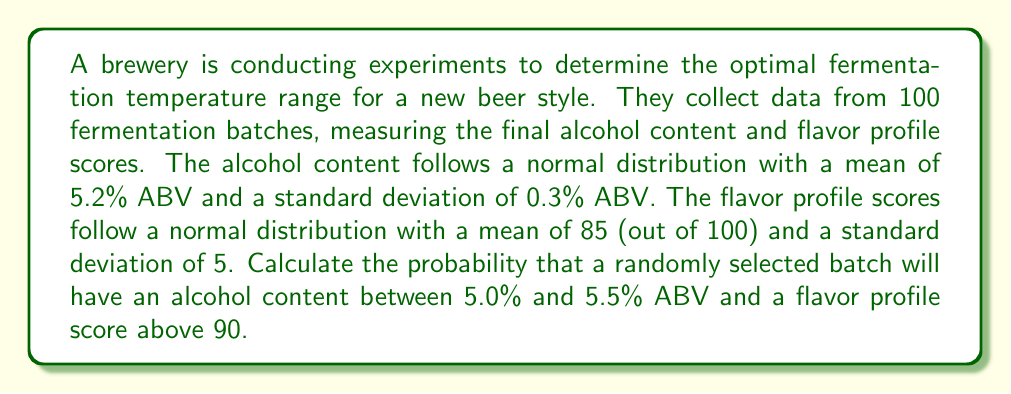Could you help me with this problem? To solve this problem, we need to use the properties of normal distributions and the concept of independence between variables.

Step 1: Calculate the probability of alcohol content between 5.0% and 5.5% ABV.
Let X be the random variable representing alcohol content.
X ~ N(μ = 5.2, σ = 0.3)

We need to find P(5.0 ≤ X ≤ 5.5)

Standardize the values:
z₁ = (5.0 - 5.2) / 0.3 = -0.67
z₂ = (5.5 - 5.2) / 0.3 = 1.00

Using the standard normal distribution table or calculator:
P(5.0 ≤ X ≤ 5.5) = P(-0.67 ≤ Z ≤ 1.00) = Φ(1.00) - Φ(-0.67) ≈ 0.8413 - 0.2514 = 0.5899

Step 2: Calculate the probability of flavor profile score above 90.
Let Y be the random variable representing flavor profile score.
Y ~ N(μ = 85, σ = 5)

We need to find P(Y > 90)

Standardize the value:
z = (90 - 85) / 5 = 1

Using the standard normal distribution table or calculator:
P(Y > 90) = 1 - P(Y ≤ 90) = 1 - Φ(1) ≈ 1 - 0.8413 = 0.1587

Step 3: Calculate the joint probability.
Assuming alcohol content and flavor profile score are independent, we multiply the probabilities:

P(5.0 ≤ X ≤ 5.5 and Y > 90) = P(5.0 ≤ X ≤ 5.5) × P(Y > 90)
= 0.5899 × 0.1587 ≈ 0.0936

Therefore, the probability that a randomly selected batch will have an alcohol content between 5.0% and 5.5% ABV and a flavor profile score above 90 is approximately 0.0936 or 9.36%.
Answer: 0.0936 